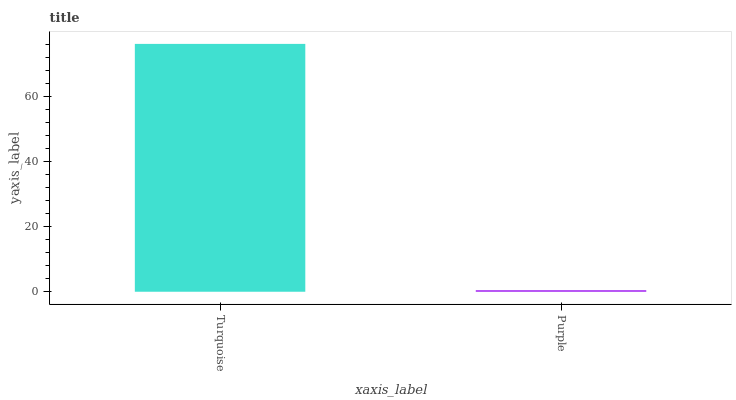Is Purple the minimum?
Answer yes or no. Yes. Is Turquoise the maximum?
Answer yes or no. Yes. Is Purple the maximum?
Answer yes or no. No. Is Turquoise greater than Purple?
Answer yes or no. Yes. Is Purple less than Turquoise?
Answer yes or no. Yes. Is Purple greater than Turquoise?
Answer yes or no. No. Is Turquoise less than Purple?
Answer yes or no. No. Is Turquoise the high median?
Answer yes or no. Yes. Is Purple the low median?
Answer yes or no. Yes. Is Purple the high median?
Answer yes or no. No. Is Turquoise the low median?
Answer yes or no. No. 